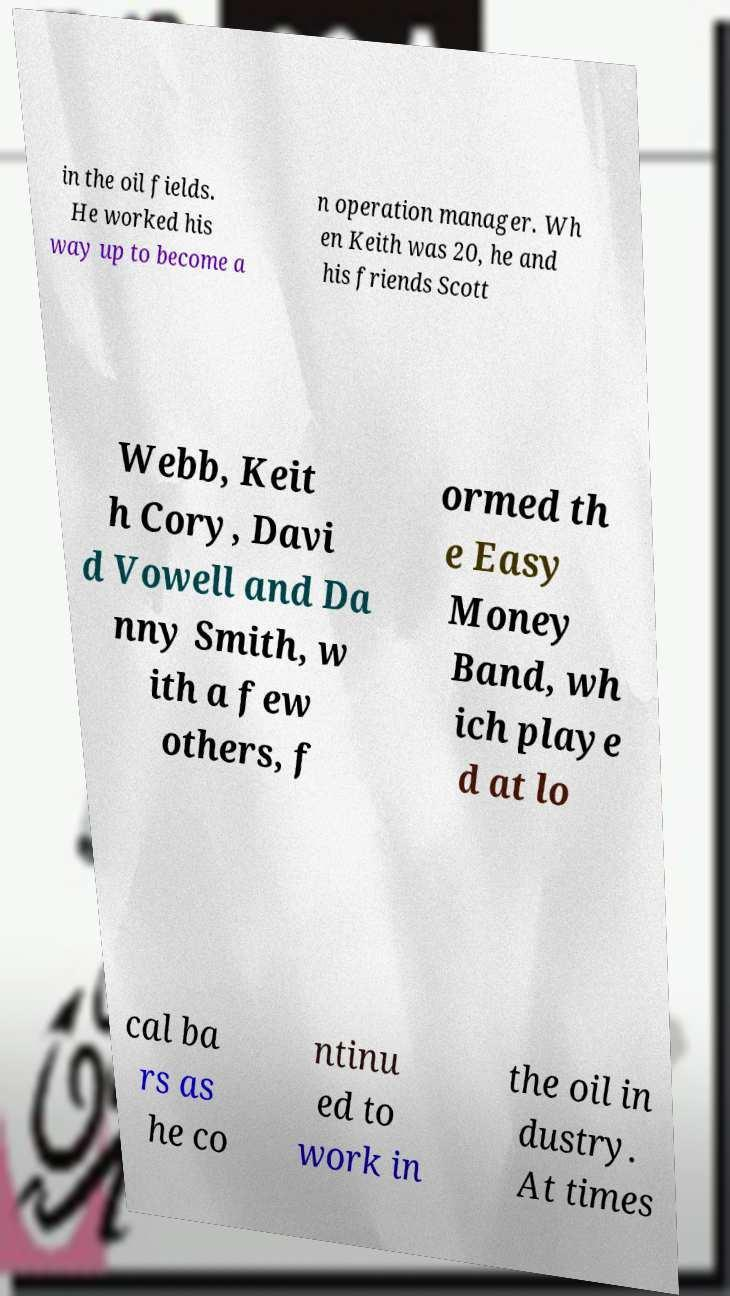Could you assist in decoding the text presented in this image and type it out clearly? in the oil fields. He worked his way up to become a n operation manager. Wh en Keith was 20, he and his friends Scott Webb, Keit h Cory, Davi d Vowell and Da nny Smith, w ith a few others, f ormed th e Easy Money Band, wh ich playe d at lo cal ba rs as he co ntinu ed to work in the oil in dustry. At times 